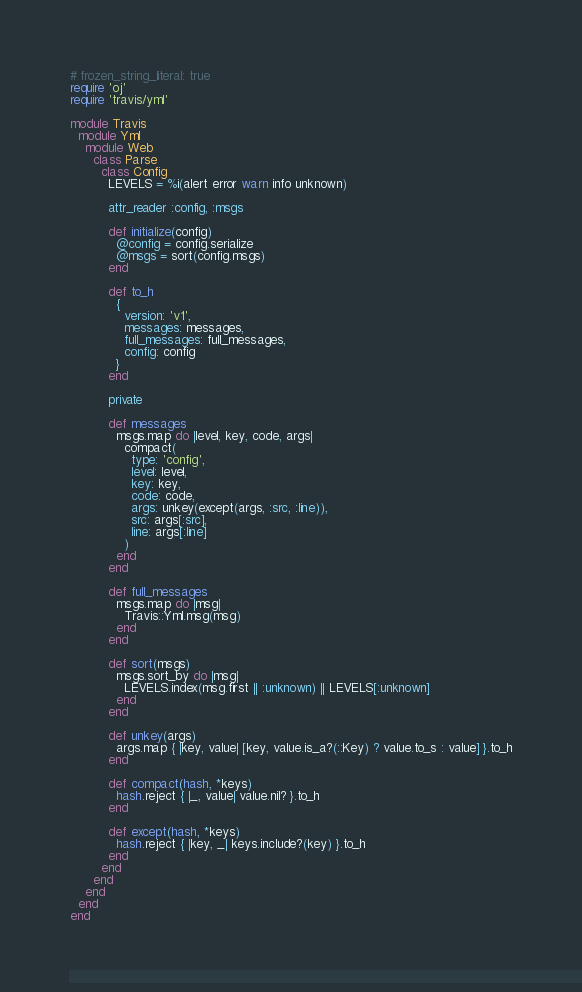Convert code to text. <code><loc_0><loc_0><loc_500><loc_500><_Ruby_># frozen_string_literal: true
require 'oj'
require 'travis/yml'

module Travis
  module Yml
    module Web
      class Parse
        class Config
          LEVELS = %i(alert error warn info unknown)

          attr_reader :config, :msgs

          def initialize(config)
            @config = config.serialize
            @msgs = sort(config.msgs)
          end

          def to_h
            {
              version: 'v1',
              messages: messages,
              full_messages: full_messages,
              config: config
            }
          end

          private

          def messages
            msgs.map do |level, key, code, args|
              compact(
                type: 'config',
                level: level,
                key: key,
                code: code,
                args: unkey(except(args, :src, :line)),
                src: args[:src],
                line: args[:line]
              )
            end
          end

          def full_messages
            msgs.map do |msg|
              Travis::Yml.msg(msg)
            end
          end

          def sort(msgs)
            msgs.sort_by do |msg|
              LEVELS.index(msg.first || :unknown) || LEVELS[:unknown]
            end
          end

          def unkey(args)
            args.map { |key, value| [key, value.is_a?(::Key) ? value.to_s : value] }.to_h
          end

          def compact(hash, *keys)
            hash.reject { |_, value| value.nil? }.to_h
          end

          def except(hash, *keys)
            hash.reject { |key, _| keys.include?(key) }.to_h
          end
        end
      end
    end
  end
end
</code> 